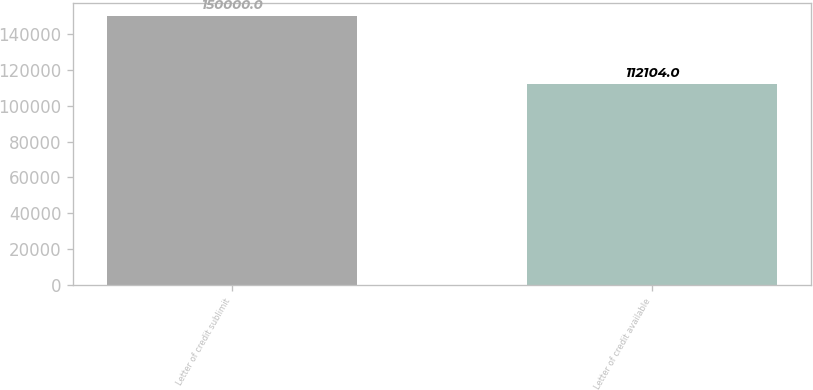Convert chart. <chart><loc_0><loc_0><loc_500><loc_500><bar_chart><fcel>Letter of credit sublimit<fcel>Letter of credit available<nl><fcel>150000<fcel>112104<nl></chart> 